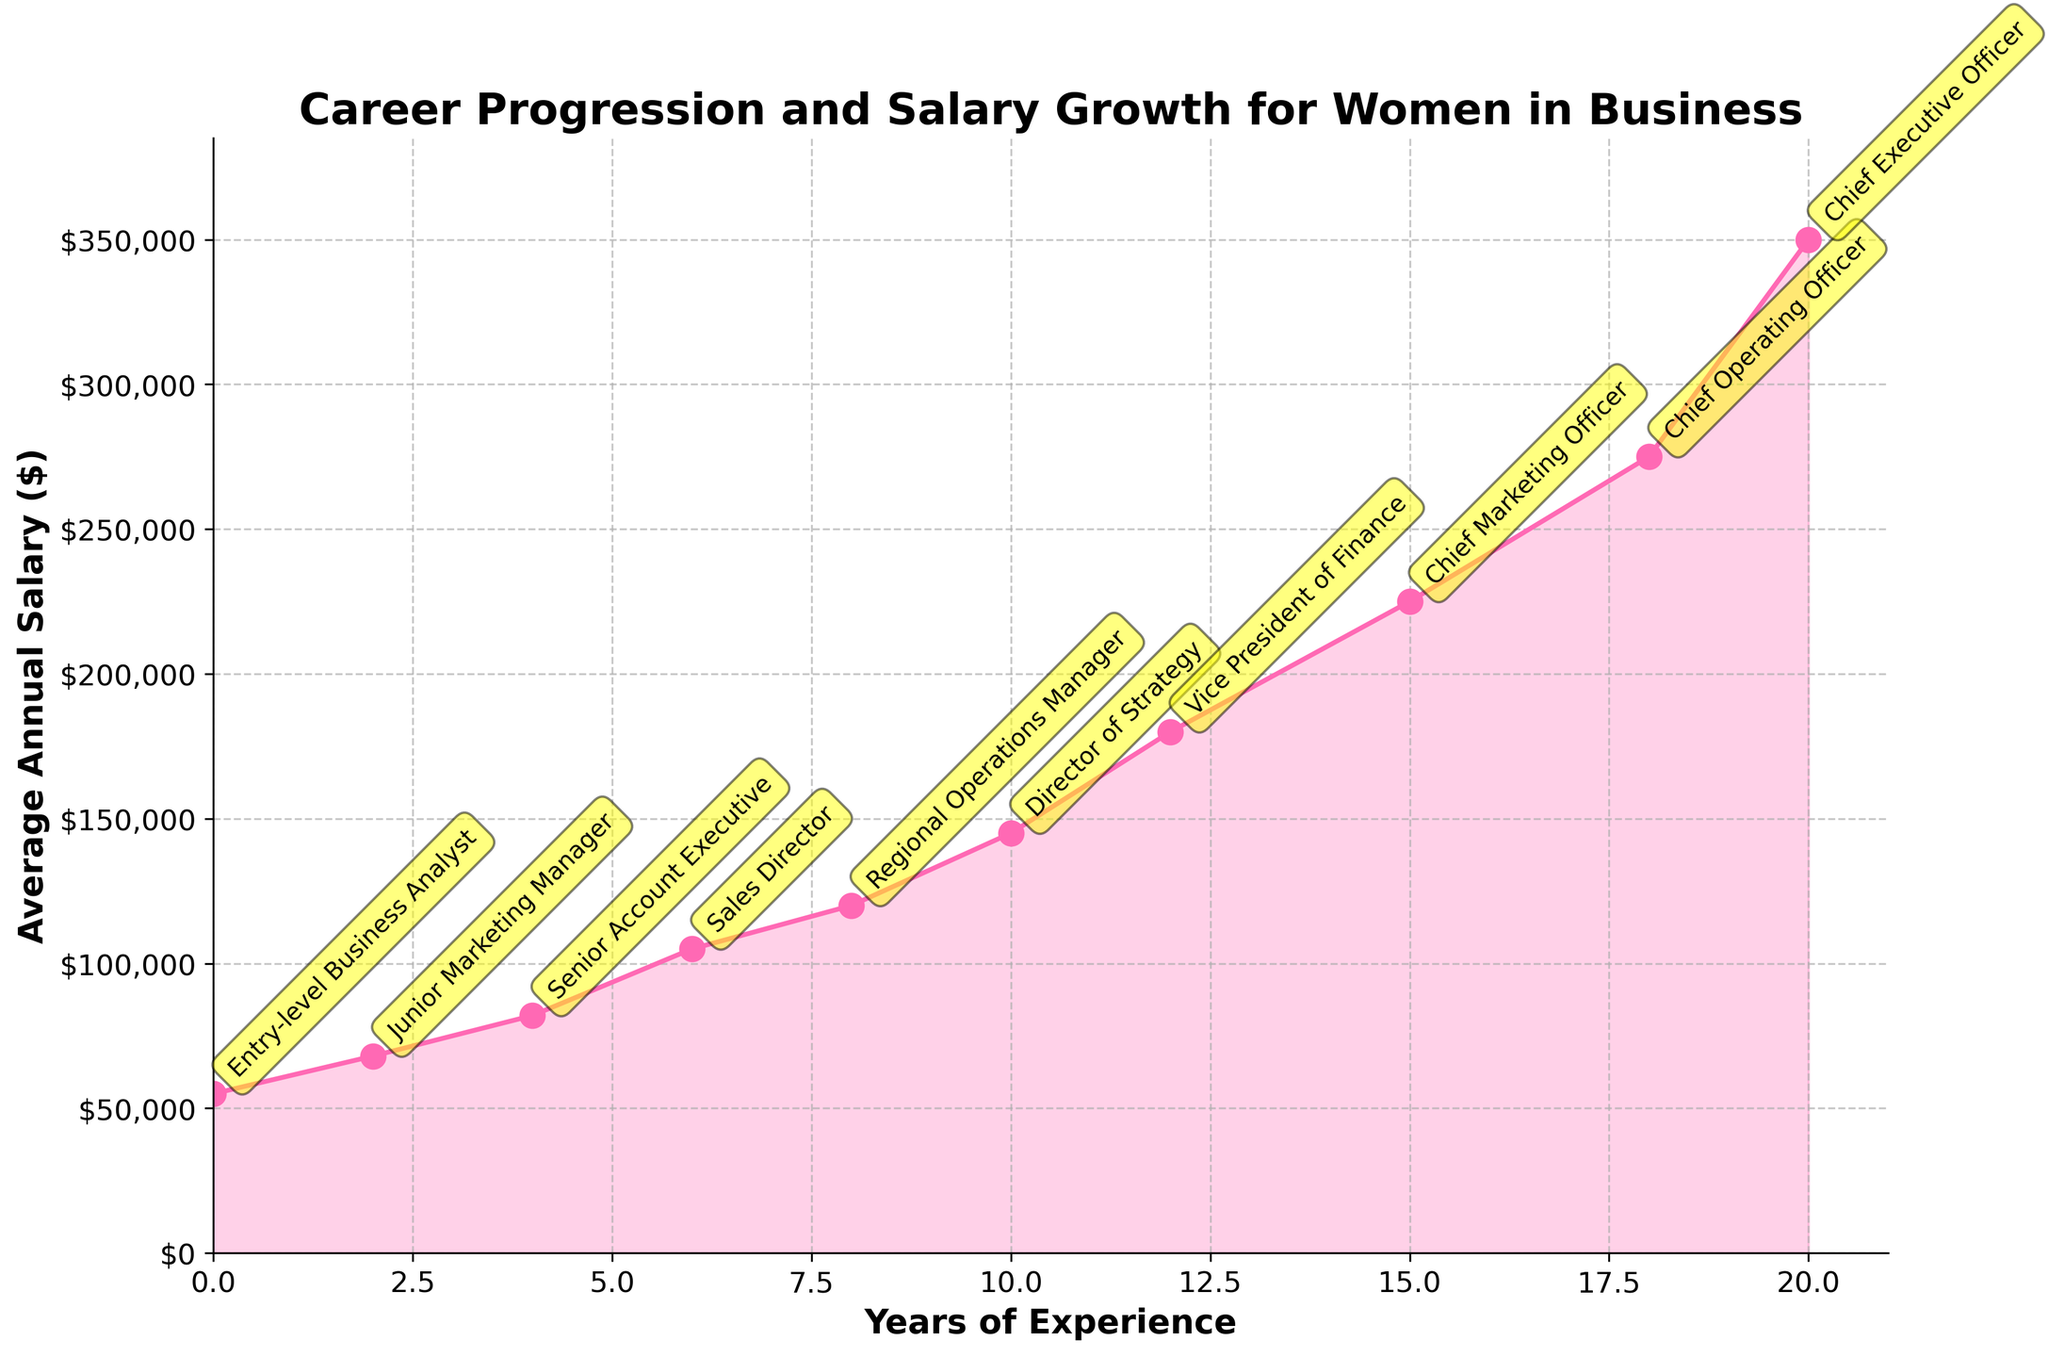what's the average annual salary of a woman with 6 years of experience? Referring to the figure, at 6 years of experience, the position listed is "Sales Director", and the corresponding salary is $105,000.
Answer: $105,000 which position requires the most years of experience? According to the figure, the "Chief Executive Officer" position requires more than 20 years of experience, the highest among all the listed positions.
Answer: Chief Executive Officer What is the difference in average annual salary between a "Junior Marketing Manager" and a "Chief Marketing Officer"? From the figure, the salary of a "Junior Marketing Manager" is $68,000, and the salary of a "Chief Marketing Officer" is $225,000. The difference is $225,000 - $68,000.
Answer: $157,000 How does the average annual salary change from an "Entry-level Business Analyst" to a "Vice President of Finance"? An "Entry-level Business Analyst" earns $55,000, and a "Vice President of Finance" earns $180,000. The change is $180,000 - $55,000.
Answer: $125,000 What is the median salary among the listed positions? To find the median salary, list all salaries in ascending order: $55,000, $68,000, $82,000, $105,000, $120,000, $145,000, $180,000, $225,000, $275,000, $350,000. The median value in this ordered list is the average of the 5th and 6th values: ($120,000 + $145,000) / 2.
Answer: $132,500 Between the "Sales Director" and the "Chief Operating Officer", which position has a faster salary growth relative to experience? Comparing the "Sales Director" with an average annual salary of $105,000 at 6 years of experience and the "Chief Operating Officer" with $275,000 at 18 years of experience, calculate the rate of salary growth: Sales Director: $105,000 / 6 years = $17,500 per year. Chief Operating Officer: $275,000 / 18 years = $15,278 per year. Thus, the Sales Director position shows a faster annual salary growth rate.
Answer: Sales Director Is the salary growth linear from entry-level positions to executive positions? By examining the plot, the rate of increase in salary appears to be non-linear, especially as the experience increases significantly at the executive level; indicating a steeper curve towards the higher end positions.
Answer: No Which position sees the highest jump in salary compared to the previous one listed? Referring to the figure, the highest jump in salary occurs between the "Chief Marketing Officer" ($225,000) and "Chief Operating Officer" ($275,000), which is a $50,000 increase.
Answer: Chief Operating Officer How much more does a "Regional Operations Manager" earn compared to a "Senior Account Executive"? From the figure, a "Regional Operations Manager" earns $120,000 and a "Senior Account Executive" earns $82,000. The difference is $120,000 - $82,000.
Answer: $38,000 Which position represents the midpoint in experience among the listed positions, and what is its corresponding salary? The midpoint in experience can be seen as the 5th position in the sequence of 10 positions. The figure shows that the "Regional Operations Manager" is this position with 8 years of experience and a salary of $120,000.
Answer: Regional Operations Manager with $120,000 